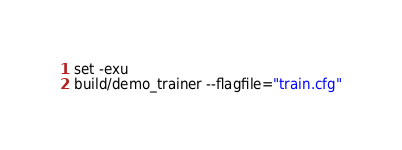Convert code to text. <code><loc_0><loc_0><loc_500><loc_500><_Bash_>
set -exu
build/demo_trainer --flagfile="train.cfg"
</code> 